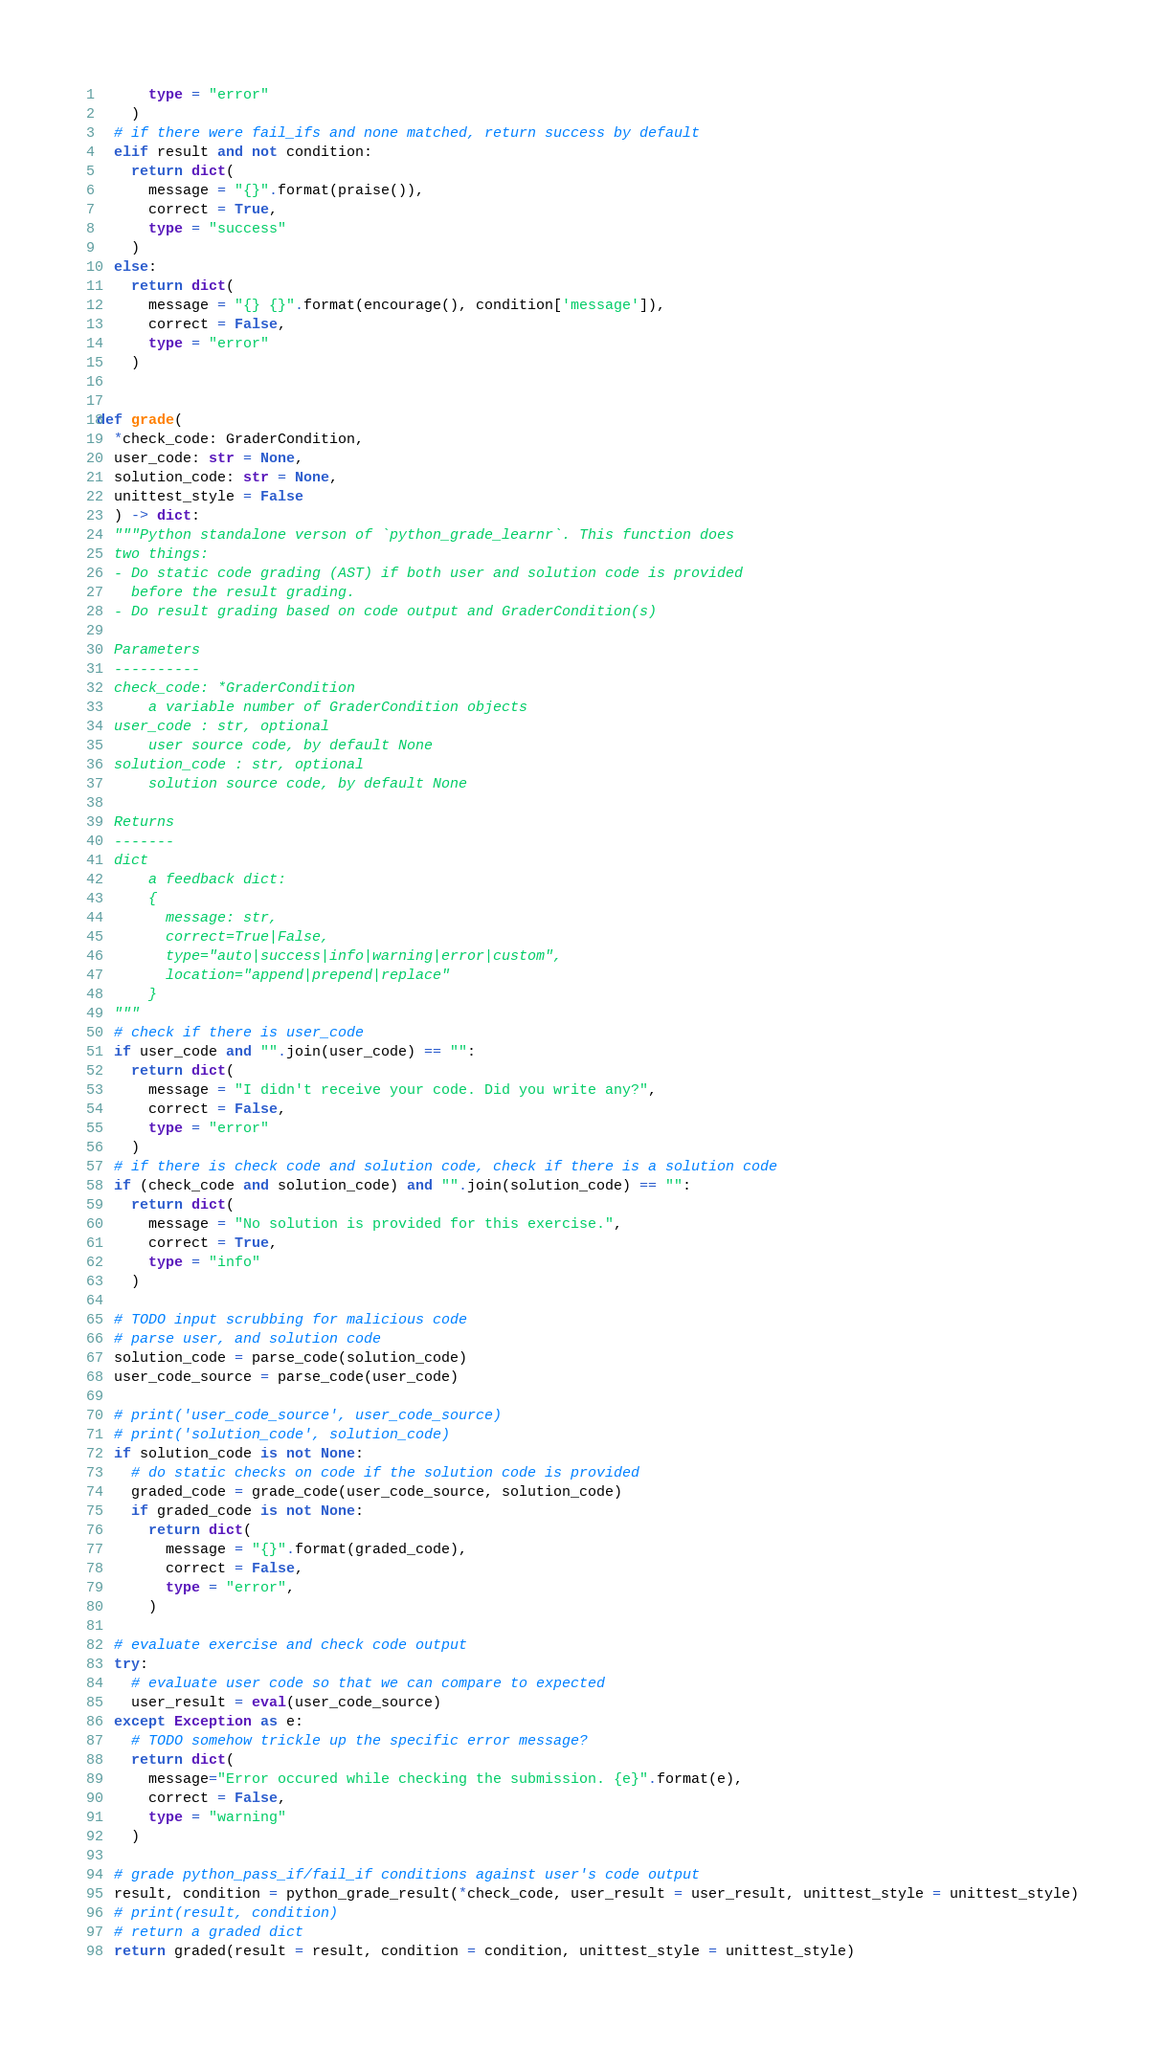Convert code to text. <code><loc_0><loc_0><loc_500><loc_500><_Python_>      type = "error"
    )
  # if there were fail_ifs and none matched, return success by default
  elif result and not condition:
    return dict(
      message = "{}".format(praise()),
      correct = True,
      type = "success"
    )
  else:
    return dict(
      message = "{} {}".format(encourage(), condition['message']), 
      correct = False, 
      type = "error"
    )


def grade(
  *check_code: GraderCondition,
  user_code: str = None, 
  solution_code: str = None,
  unittest_style = False
  ) -> dict:
  """Python standalone verson of `python_grade_learnr`. This function does
  two things:
  - Do static code grading (AST) if both user and solution code is provided
    before the result grading.
  - Do result grading based on code output and GraderCondition(s)

  Parameters
  ----------
  check_code: *GraderCondition
      a variable number of GraderCondition objects
  user_code : str, optional
      user source code, by default None
  solution_code : str, optional
      solution source code, by default None

  Returns
  -------
  dict
      a feedback dict:
      {
        message: str,
        correct=True|False,
        type="auto|success|info|warning|error|custom",
        location="append|prepend|replace"
      }
  """
  # check if there is user_code
  if user_code and "".join(user_code) == "":
    return dict(
      message = "I didn't receive your code. Did you write any?",
      correct = False,
      type = "error"
    )
  # if there is check code and solution code, check if there is a solution code
  if (check_code and solution_code) and "".join(solution_code) == "":
    return dict(
      message = "No solution is provided for this exercise.",
      correct = True,
      type = "info"
    )
    
  # TODO input scrubbing for malicious code
  # parse user, and solution code
  solution_code = parse_code(solution_code)
  user_code_source = parse_code(user_code)

  # print('user_code_source', user_code_source)
  # print('solution_code', solution_code)
  if solution_code is not None:
    # do static checks on code if the solution code is provided
    graded_code = grade_code(user_code_source, solution_code)
    if graded_code is not None:
      return dict(
        message = "{}".format(graded_code),
        correct = False,
        type = "error", 
      )

  # evaluate exercise and check code output
  try:
    # evaluate user code so that we can compare to expected
    user_result = eval(user_code_source)
  except Exception as e:
    # TODO somehow trickle up the specific error message?
    return dict(
      message="Error occured while checking the submission. {e}".format(e),
      correct = False, 
      type = "warning"
    )

  # grade python_pass_if/fail_if conditions against user's code output
  result, condition = python_grade_result(*check_code, user_result = user_result, unittest_style = unittest_style)
  # print(result, condition)
  # return a graded dict
  return graded(result = result, condition = condition, unittest_style = unittest_style)

</code> 